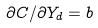Convert formula to latex. <formula><loc_0><loc_0><loc_500><loc_500>\partial C / \partial Y _ { d } = b</formula> 